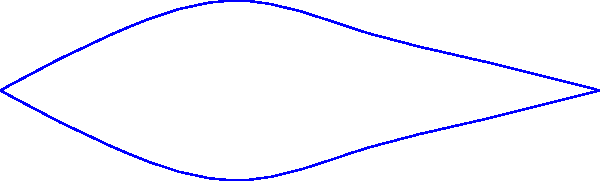As an environmental scientist, you're tasked with estimating the volume of a small lake for a habitat assessment. The lake is approximately 100 meters long, and you've taken four cross-sectional area measurements at equal intervals along its length: $A_1 = 120$ m², $A_2 = 180$ m², $A_3 = 150$ m², and $A_4 = 90$ m². Using the trapezoidal rule, estimate the volume of the lake in cubic meters. To estimate the volume of the lake using the trapezoidal rule, we'll follow these steps:

1) The trapezoidal rule for volume estimation is given by:

   $$V \approx \frac{h}{2}(A_1 + A_n + 2(A_2 + A_3 + ... + A_{n-1}))$$

   Where $h$ is the distance between cross-sections, $A_1$ and $A_n$ are the first and last cross-sectional areas, and $A_2$ to $A_{n-1}$ are the intermediate areas.

2) In this case, we have 4 cross-sections over a 100m length, so $h = 100/3 = 33.33$ m.

3) Substituting our values into the formula:

   $$V \approx \frac{33.33}{2}(120 + 90 + 2(180 + 150))$$

4) Simplify inside the parentheses:
   
   $$V \approx \frac{33.33}{2}(210 + 2(330))$$
   $$V \approx \frac{33.33}{2}(210 + 660)$$
   $$V \approx \frac{33.33}{2}(870)$$

5) Multiply:
   
   $$V \approx 16.665 * 870 = 14,498.55$$

6) Round to a reasonable number of significant figures:

   $$V \approx 14,500 \text{ m}^3$$
Answer: 14,500 m³ 